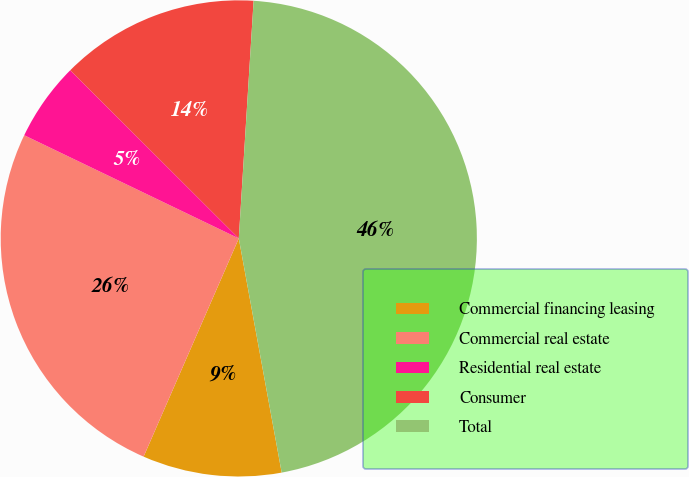Convert chart to OTSL. <chart><loc_0><loc_0><loc_500><loc_500><pie_chart><fcel>Commercial financing leasing<fcel>Commercial real estate<fcel>Residential real estate<fcel>Consumer<fcel>Total<nl><fcel>9.43%<fcel>25.59%<fcel>5.35%<fcel>13.51%<fcel>46.13%<nl></chart> 